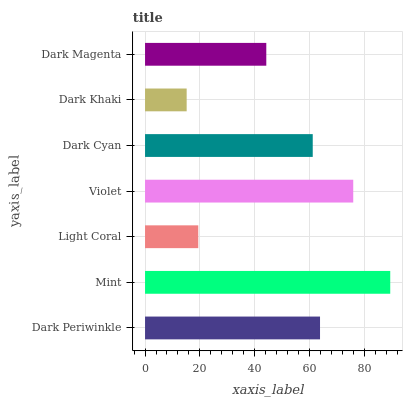Is Dark Khaki the minimum?
Answer yes or no. Yes. Is Mint the maximum?
Answer yes or no. Yes. Is Light Coral the minimum?
Answer yes or no. No. Is Light Coral the maximum?
Answer yes or no. No. Is Mint greater than Light Coral?
Answer yes or no. Yes. Is Light Coral less than Mint?
Answer yes or no. Yes. Is Light Coral greater than Mint?
Answer yes or no. No. Is Mint less than Light Coral?
Answer yes or no. No. Is Dark Cyan the high median?
Answer yes or no. Yes. Is Dark Cyan the low median?
Answer yes or no. Yes. Is Dark Khaki the high median?
Answer yes or no. No. Is Dark Periwinkle the low median?
Answer yes or no. No. 